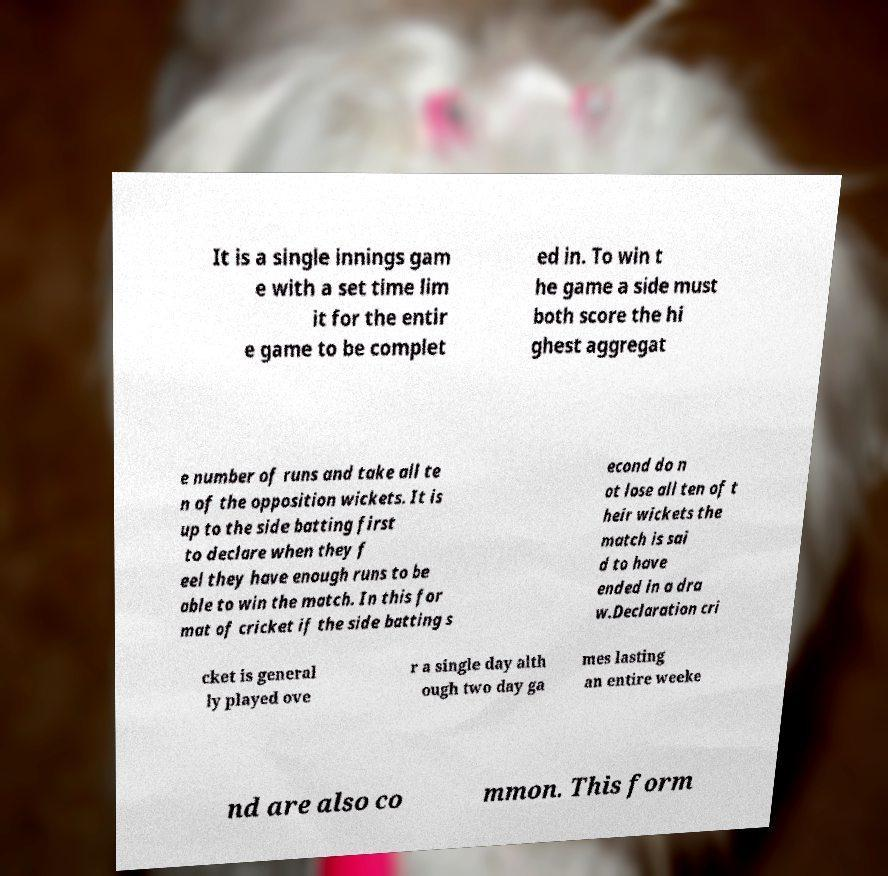Could you assist in decoding the text presented in this image and type it out clearly? It is a single innings gam e with a set time lim it for the entir e game to be complet ed in. To win t he game a side must both score the hi ghest aggregat e number of runs and take all te n of the opposition wickets. It is up to the side batting first to declare when they f eel they have enough runs to be able to win the match. In this for mat of cricket if the side batting s econd do n ot lose all ten of t heir wickets the match is sai d to have ended in a dra w.Declaration cri cket is general ly played ove r a single day alth ough two day ga mes lasting an entire weeke nd are also co mmon. This form 